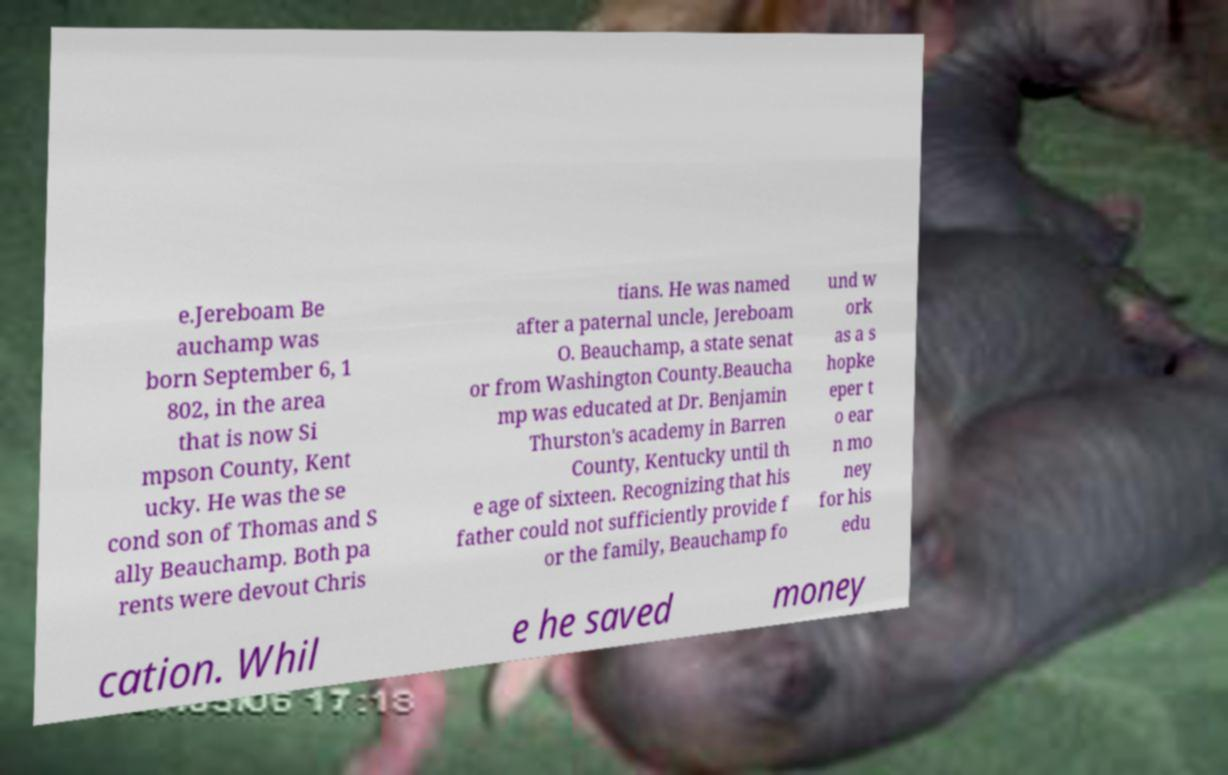Please read and relay the text visible in this image. What does it say? e.Jereboam Be auchamp was born September 6, 1 802, in the area that is now Si mpson County, Kent ucky. He was the se cond son of Thomas and S ally Beauchamp. Both pa rents were devout Chris tians. He was named after a paternal uncle, Jereboam O. Beauchamp, a state senat or from Washington County.Beaucha mp was educated at Dr. Benjamin Thurston's academy in Barren County, Kentucky until th e age of sixteen. Recognizing that his father could not sufficiently provide f or the family, Beauchamp fo und w ork as a s hopke eper t o ear n mo ney for his edu cation. Whil e he saved money 